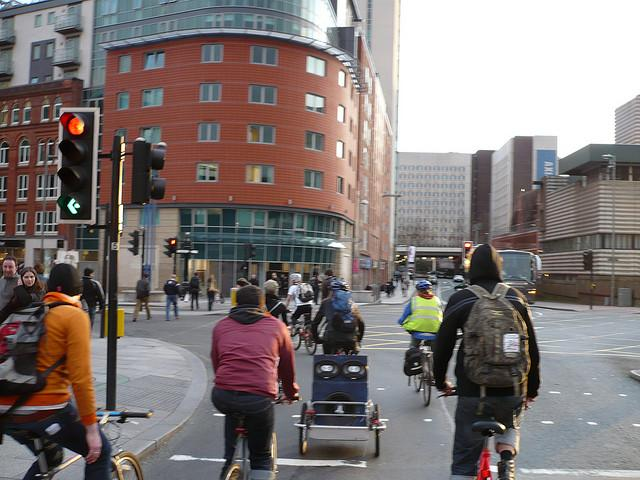What type of action is allowed by the traffic light?

Choices:
A) straight travel
B) left turn
C) pedestrian crossing
D) right turn left turn 